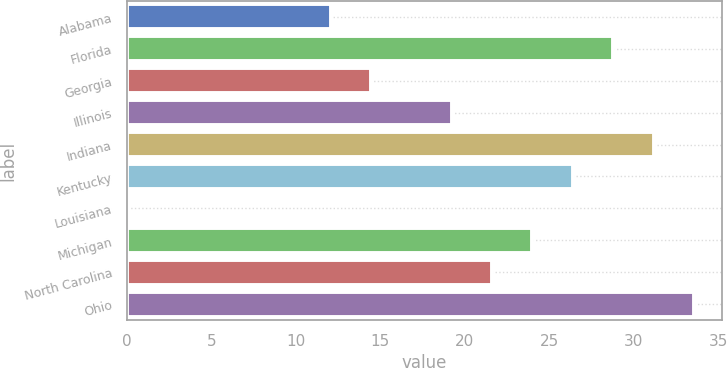<chart> <loc_0><loc_0><loc_500><loc_500><bar_chart><fcel>Alabama<fcel>Florida<fcel>Georgia<fcel>Illinois<fcel>Indiana<fcel>Kentucky<fcel>Louisiana<fcel>Michigan<fcel>North Carolina<fcel>Ohio<nl><fcel>12.05<fcel>28.78<fcel>14.44<fcel>19.22<fcel>31.17<fcel>26.39<fcel>0.1<fcel>24<fcel>21.61<fcel>33.56<nl></chart> 